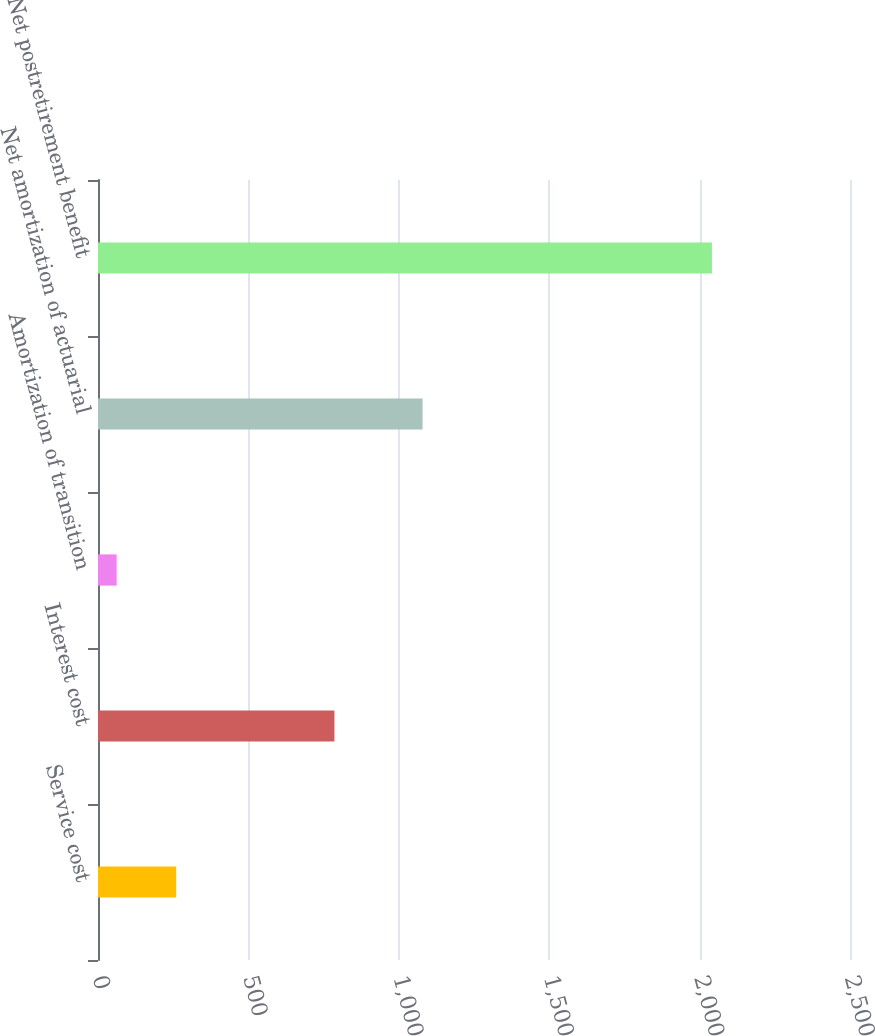Convert chart to OTSL. <chart><loc_0><loc_0><loc_500><loc_500><bar_chart><fcel>Service cost<fcel>Interest cost<fcel>Amortization of transition<fcel>Net amortization of actuarial<fcel>Net postretirement benefit<nl><fcel>259.9<fcel>786<fcel>62<fcel>1079<fcel>2041<nl></chart> 